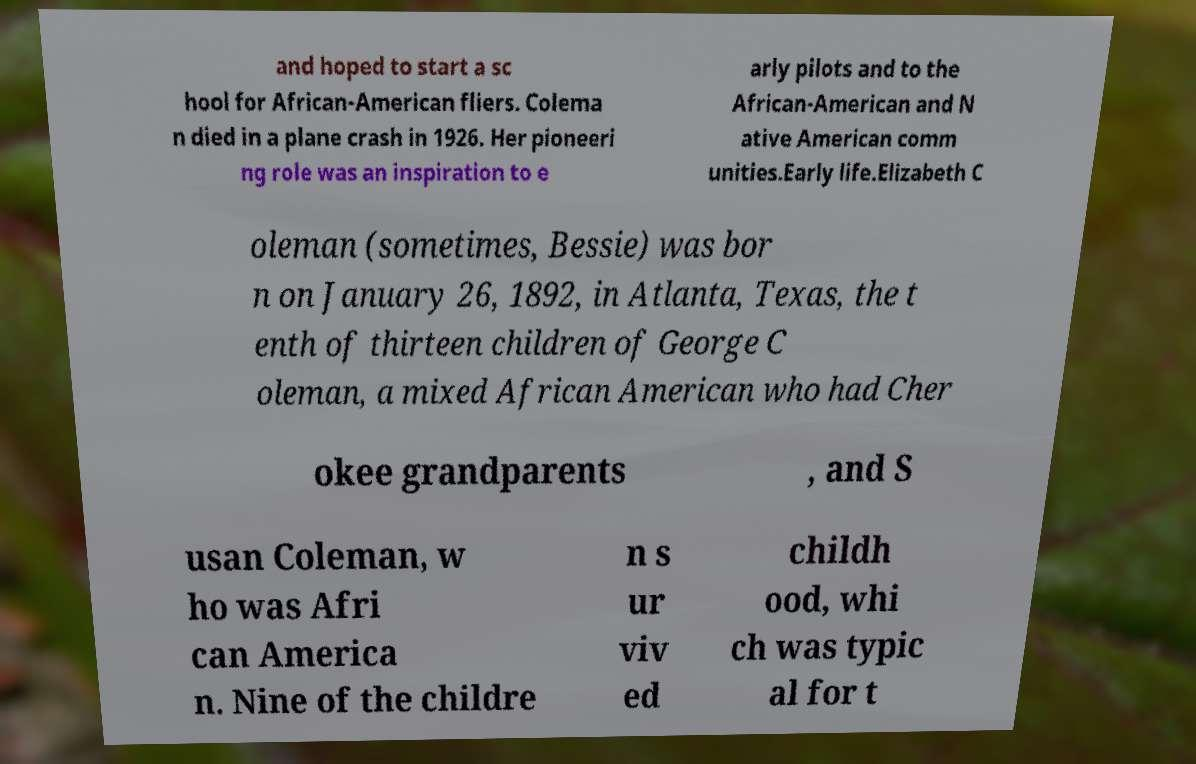Please read and relay the text visible in this image. What does it say? and hoped to start a sc hool for African-American fliers. Colema n died in a plane crash in 1926. Her pioneeri ng role was an inspiration to e arly pilots and to the African-American and N ative American comm unities.Early life.Elizabeth C oleman (sometimes, Bessie) was bor n on January 26, 1892, in Atlanta, Texas, the t enth of thirteen children of George C oleman, a mixed African American who had Cher okee grandparents , and S usan Coleman, w ho was Afri can America n. Nine of the childre n s ur viv ed childh ood, whi ch was typic al for t 